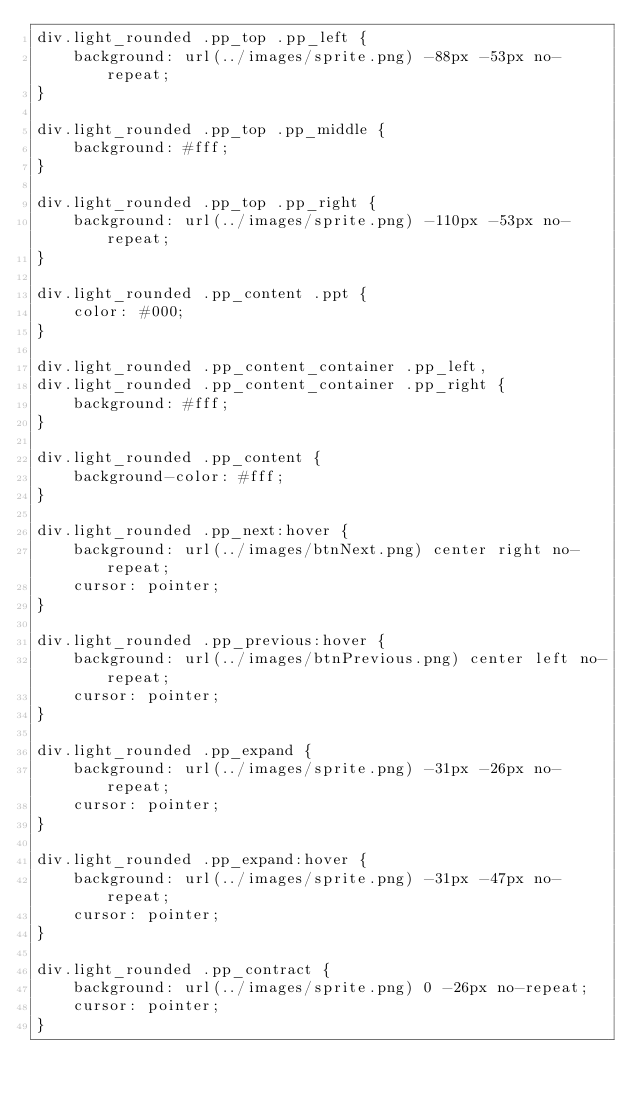Convert code to text. <code><loc_0><loc_0><loc_500><loc_500><_CSS_>div.light_rounded .pp_top .pp_left {
    background: url(../images/sprite.png) -88px -53px no-repeat;
}

div.light_rounded .pp_top .pp_middle {
    background: #fff;
}

div.light_rounded .pp_top .pp_right {
    background: url(../images/sprite.png) -110px -53px no-repeat;
}

div.light_rounded .pp_content .ppt {
    color: #000;
}

div.light_rounded .pp_content_container .pp_left,
div.light_rounded .pp_content_container .pp_right {
    background: #fff;
}

div.light_rounded .pp_content {
    background-color: #fff;
}

div.light_rounded .pp_next:hover {
    background: url(../images/btnNext.png) center right no-repeat;
    cursor: pointer;
}

div.light_rounded .pp_previous:hover {
    background: url(../images/btnPrevious.png) center left no-repeat;
    cursor: pointer;
}

div.light_rounded .pp_expand {
    background: url(../images/sprite.png) -31px -26px no-repeat;
    cursor: pointer;
}

div.light_rounded .pp_expand:hover {
    background: url(../images/sprite.png) -31px -47px no-repeat;
    cursor: pointer;
}

div.light_rounded .pp_contract {
    background: url(../images/sprite.png) 0 -26px no-repeat;
    cursor: pointer;
}
</code> 